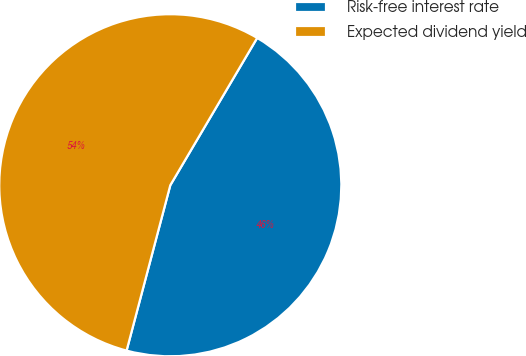Convert chart. <chart><loc_0><loc_0><loc_500><loc_500><pie_chart><fcel>Risk-free interest rate<fcel>Expected dividend yield<nl><fcel>45.63%<fcel>54.37%<nl></chart> 